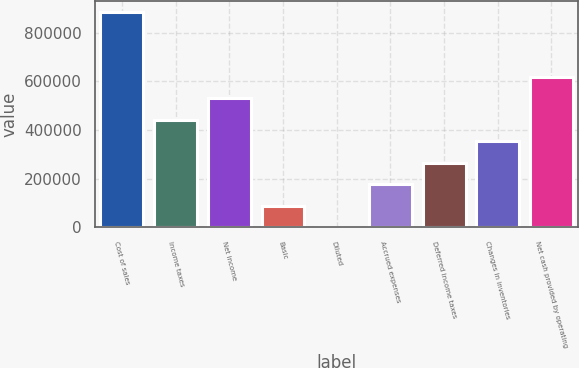Convert chart to OTSL. <chart><loc_0><loc_0><loc_500><loc_500><bar_chart><fcel>Cost of sales<fcel>Income taxes<fcel>Net income<fcel>Basic<fcel>Diluted<fcel>Accrued expenses<fcel>Deferred income taxes<fcel>Changes in inventories<fcel>Net cash provided by operating<nl><fcel>885562<fcel>442782<fcel>531338<fcel>88557.6<fcel>1.59<fcel>177114<fcel>265670<fcel>354226<fcel>619894<nl></chart> 